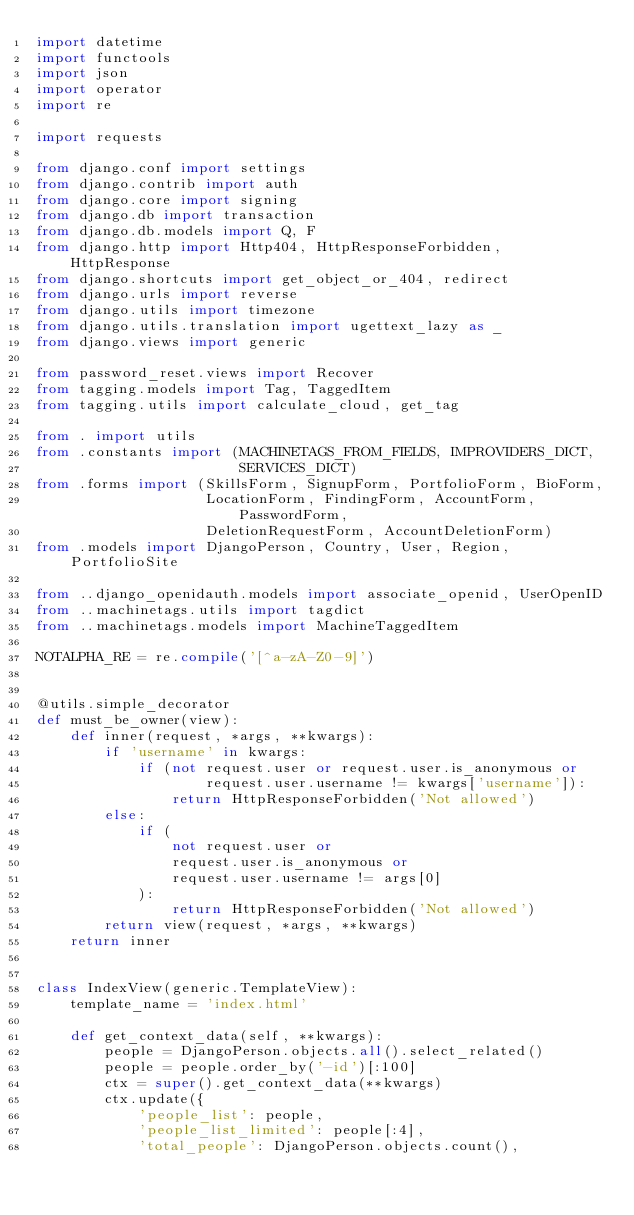<code> <loc_0><loc_0><loc_500><loc_500><_Python_>import datetime
import functools
import json
import operator
import re

import requests

from django.conf import settings
from django.contrib import auth
from django.core import signing
from django.db import transaction
from django.db.models import Q, F
from django.http import Http404, HttpResponseForbidden, HttpResponse
from django.shortcuts import get_object_or_404, redirect
from django.urls import reverse
from django.utils import timezone
from django.utils.translation import ugettext_lazy as _
from django.views import generic

from password_reset.views import Recover
from tagging.models import Tag, TaggedItem
from tagging.utils import calculate_cloud, get_tag

from . import utils
from .constants import (MACHINETAGS_FROM_FIELDS, IMPROVIDERS_DICT,
                        SERVICES_DICT)
from .forms import (SkillsForm, SignupForm, PortfolioForm, BioForm,
                    LocationForm, FindingForm, AccountForm, PasswordForm,
                    DeletionRequestForm, AccountDeletionForm)
from .models import DjangoPerson, Country, User, Region, PortfolioSite

from ..django_openidauth.models import associate_openid, UserOpenID
from ..machinetags.utils import tagdict
from ..machinetags.models import MachineTaggedItem

NOTALPHA_RE = re.compile('[^a-zA-Z0-9]')


@utils.simple_decorator
def must_be_owner(view):
    def inner(request, *args, **kwargs):
        if 'username' in kwargs:
            if (not request.user or request.user.is_anonymous or
                    request.user.username != kwargs['username']):
                return HttpResponseForbidden('Not allowed')
        else:
            if (
                not request.user or
                request.user.is_anonymous or
                request.user.username != args[0]
            ):
                return HttpResponseForbidden('Not allowed')
        return view(request, *args, **kwargs)
    return inner


class IndexView(generic.TemplateView):
    template_name = 'index.html'

    def get_context_data(self, **kwargs):
        people = DjangoPerson.objects.all().select_related()
        people = people.order_by('-id')[:100]
        ctx = super().get_context_data(**kwargs)
        ctx.update({
            'people_list': people,
            'people_list_limited': people[:4],
            'total_people': DjangoPerson.objects.count(),</code> 